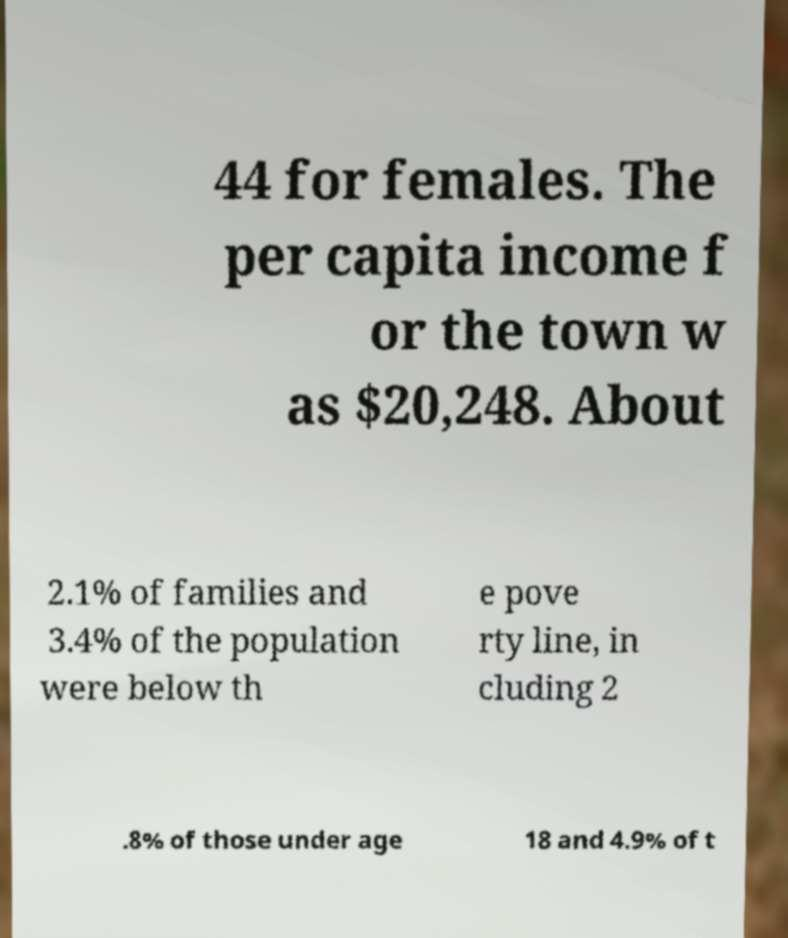Can you read and provide the text displayed in the image?This photo seems to have some interesting text. Can you extract and type it out for me? 44 for females. The per capita income f or the town w as $20,248. About 2.1% of families and 3.4% of the population were below th e pove rty line, in cluding 2 .8% of those under age 18 and 4.9% of t 